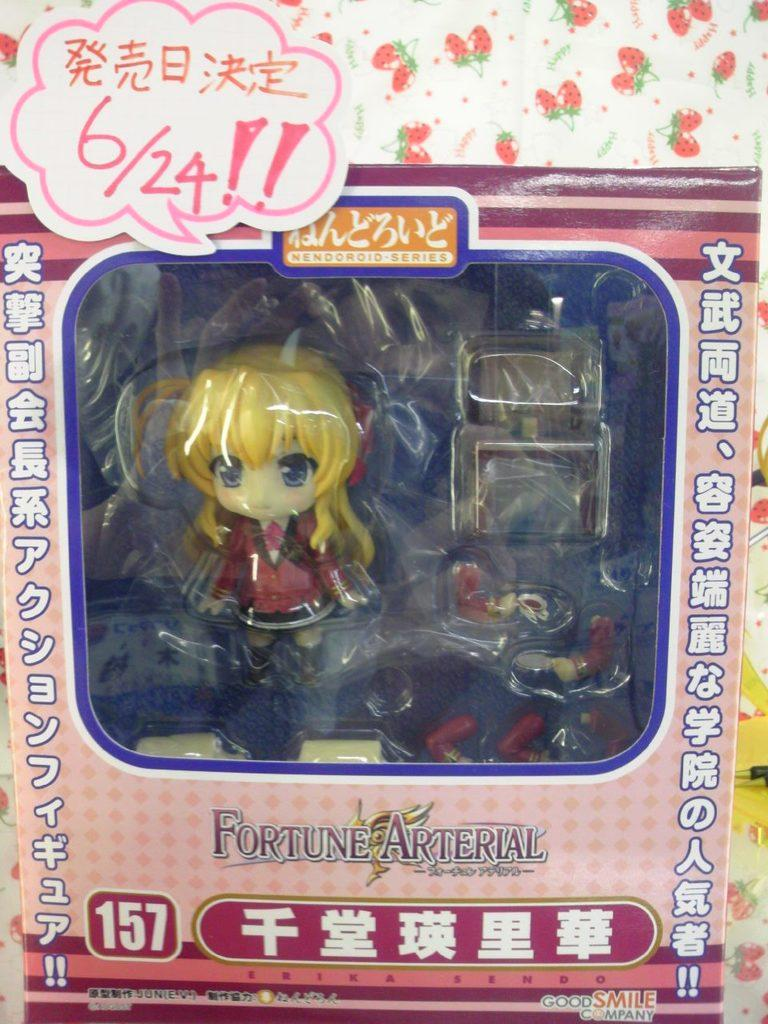What is placed in the carton in the image? There is a toy placed in a carton in the image. What can be seen in the background of the image? There is a wall in the background of the image. What is visible in the image besides the toy and the wall? Text is visible in the image. What language is the toy speaking in the image? The toy is not speaking in the image, and therefore no language can be identified. 